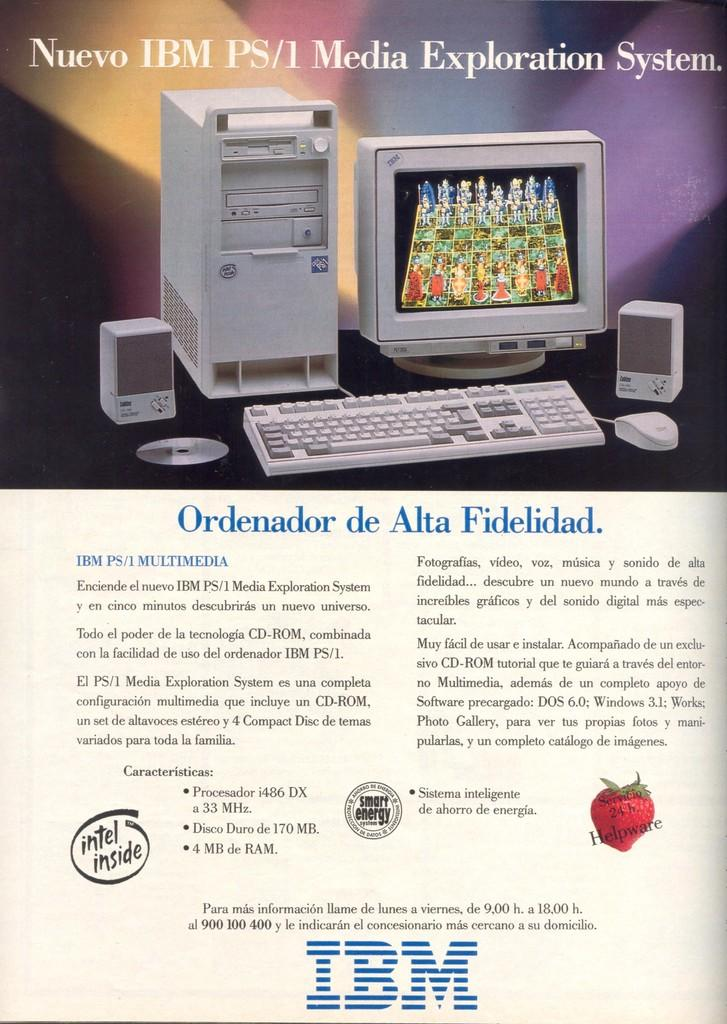<image>
Give a short and clear explanation of the subsequent image. an old advertisement for an IBM computer id not written in English 